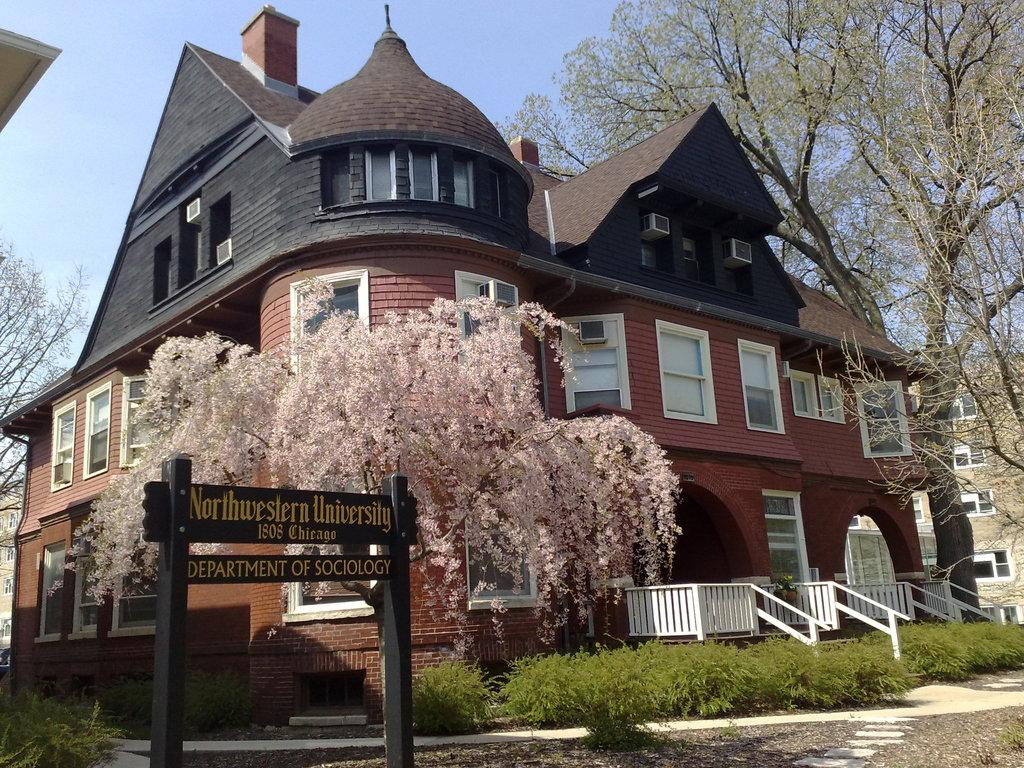What is the main object in the image? There is a board in the image. What type of vegetation can be seen at the bottom of the image? Plants are present at the bottom of the image. What other natural elements are visible in the image? Trees are visible in the image. What type of man-made structure is present in the image? There is a building in the image. What can be seen in the background of the image? The sky is visible in the background of the image. What type of hope is being expressed by the group of people in the image? There is no group of people present in the image, and therefore no expression of hope can be observed. 